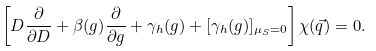<formula> <loc_0><loc_0><loc_500><loc_500>\left [ D \frac { \partial } { \partial D } + \beta ( g ) \frac { \partial } { \partial g } + \gamma _ { h } ( g ) + [ \gamma _ { h } ( g ) ] _ { \mu _ { S } = 0 } \right ] \chi ( \vec { q } ) = 0 .</formula> 